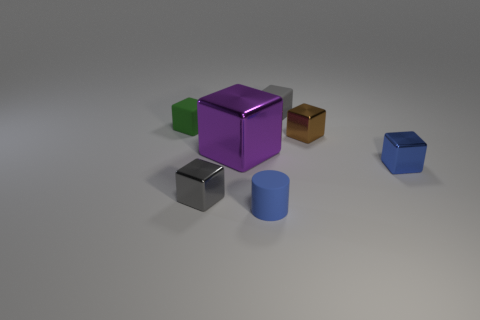There is a small gray object that is on the right side of the rubber object in front of the gray metallic object; what is its shape?
Provide a short and direct response. Cube. There is a rubber cube right of the tiny green thing; how big is it?
Give a very brief answer. Small. Is the material of the cylinder the same as the small brown cube?
Provide a short and direct response. No. There is a blue thing that is the same material as the green thing; what is its shape?
Provide a short and direct response. Cylinder. Is there any other thing that is the same color as the cylinder?
Ensure brevity in your answer.  Yes. There is a matte block that is behind the small green object; what is its color?
Offer a very short reply. Gray. Is the color of the matte thing that is in front of the green rubber thing the same as the large object?
Provide a succinct answer. No. There is a small blue object that is the same shape as the large thing; what is its material?
Your answer should be very brief. Metal. How many brown things are the same size as the blue metallic cube?
Your answer should be very brief. 1. The large thing is what shape?
Provide a succinct answer. Cube. 